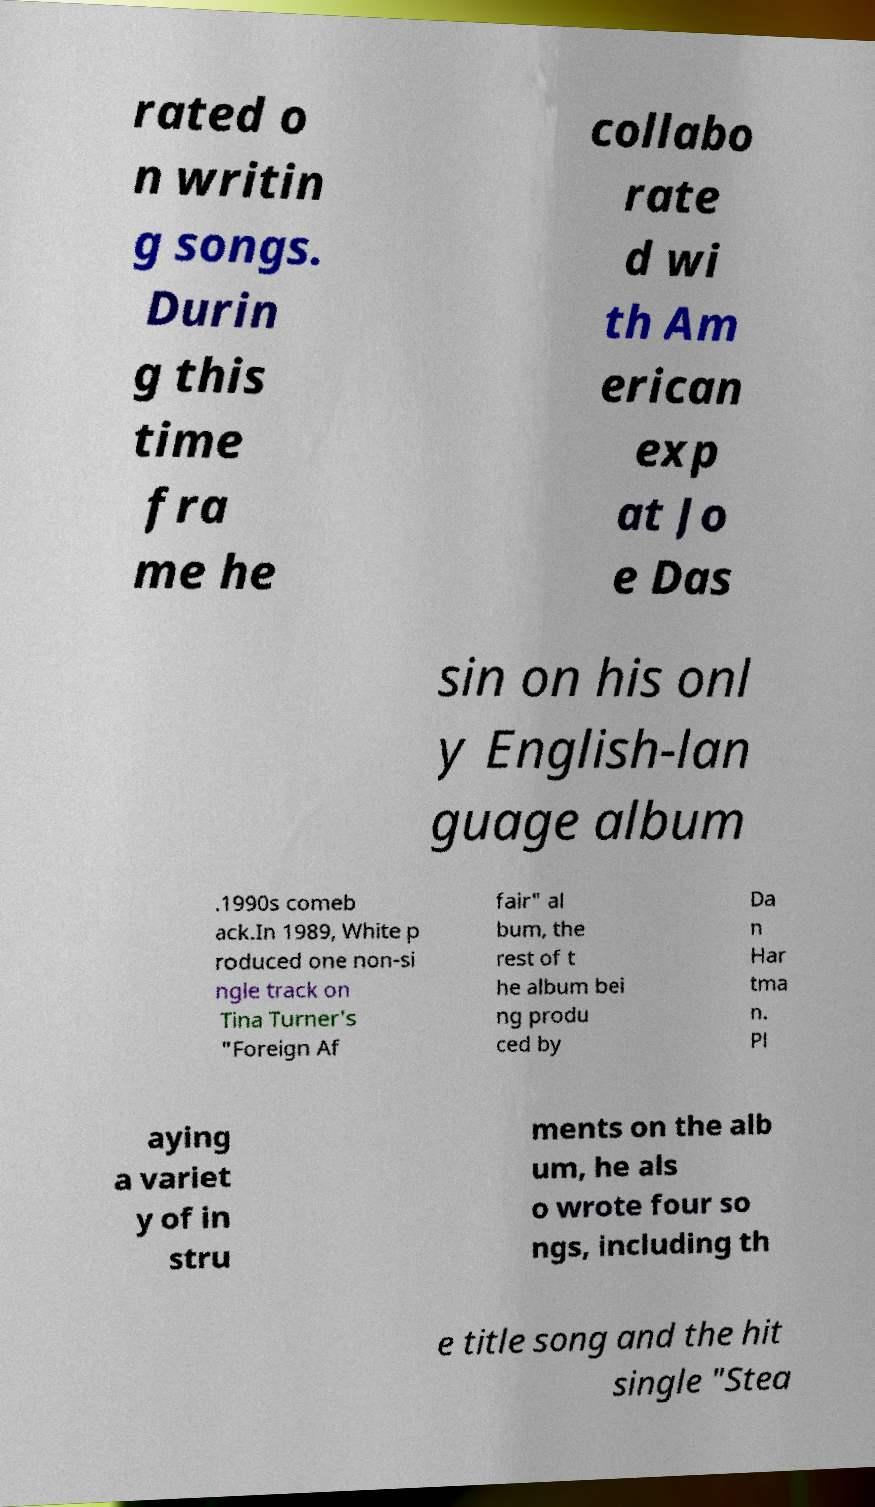Please read and relay the text visible in this image. What does it say? rated o n writin g songs. Durin g this time fra me he collabo rate d wi th Am erican exp at Jo e Das sin on his onl y English-lan guage album .1990s comeb ack.In 1989, White p roduced one non-si ngle track on Tina Turner's "Foreign Af fair" al bum, the rest of t he album bei ng produ ced by Da n Har tma n. Pl aying a variet y of in stru ments on the alb um, he als o wrote four so ngs, including th e title song and the hit single "Stea 